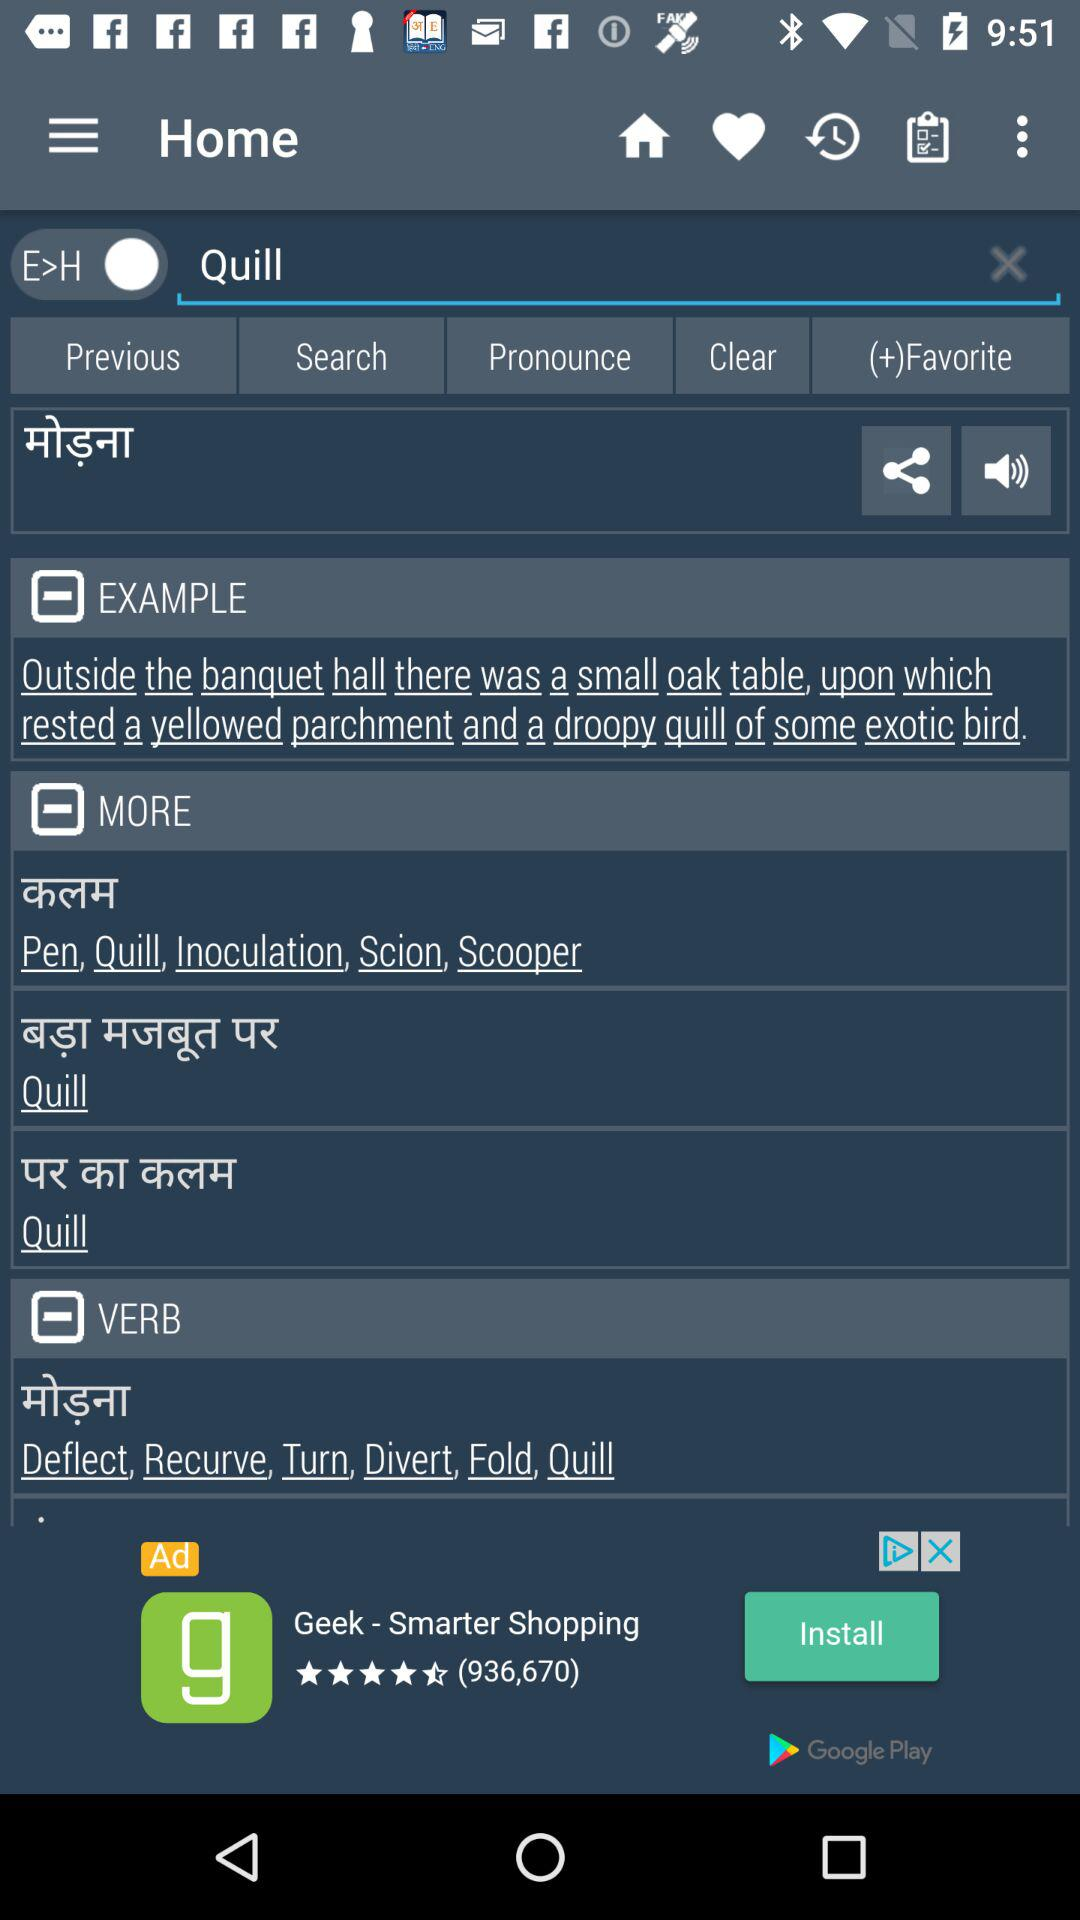How many text inputs are on the screen?
Answer the question using a single word or phrase. 1 